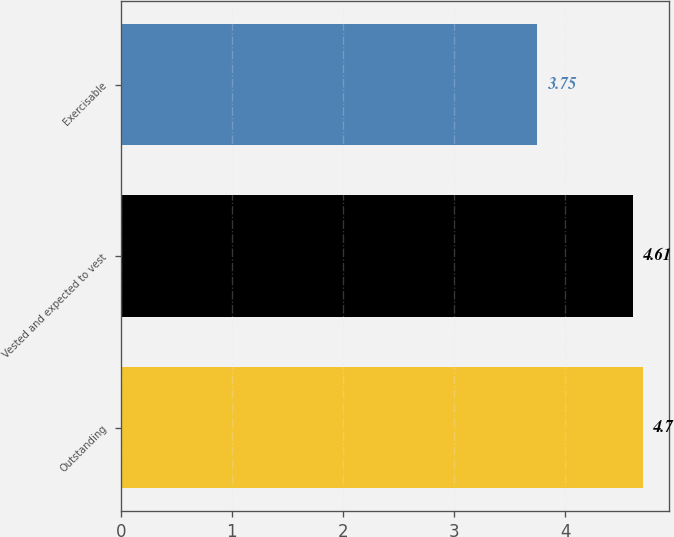<chart> <loc_0><loc_0><loc_500><loc_500><bar_chart><fcel>Outstanding<fcel>Vested and expected to vest<fcel>Exercisable<nl><fcel>4.7<fcel>4.61<fcel>3.75<nl></chart> 